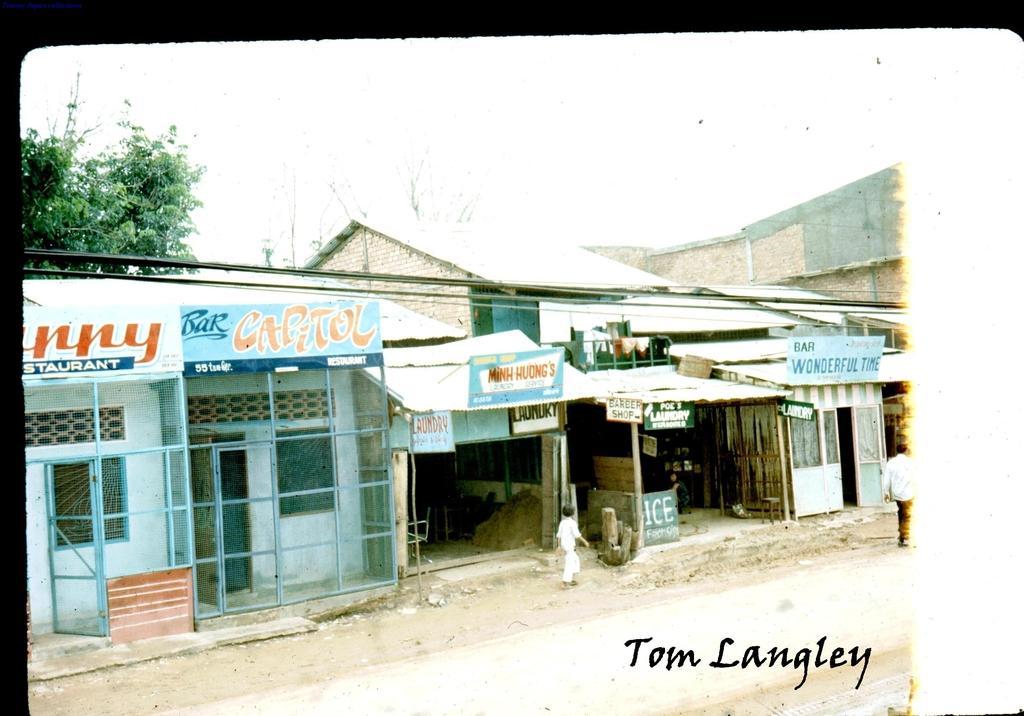How would you summarize this image in a sentence or two? In this image I can see a text and two persons on the road. In the background I can shops, boards, houses and trees. On the top I can see the sky. This image is taken during a day. 